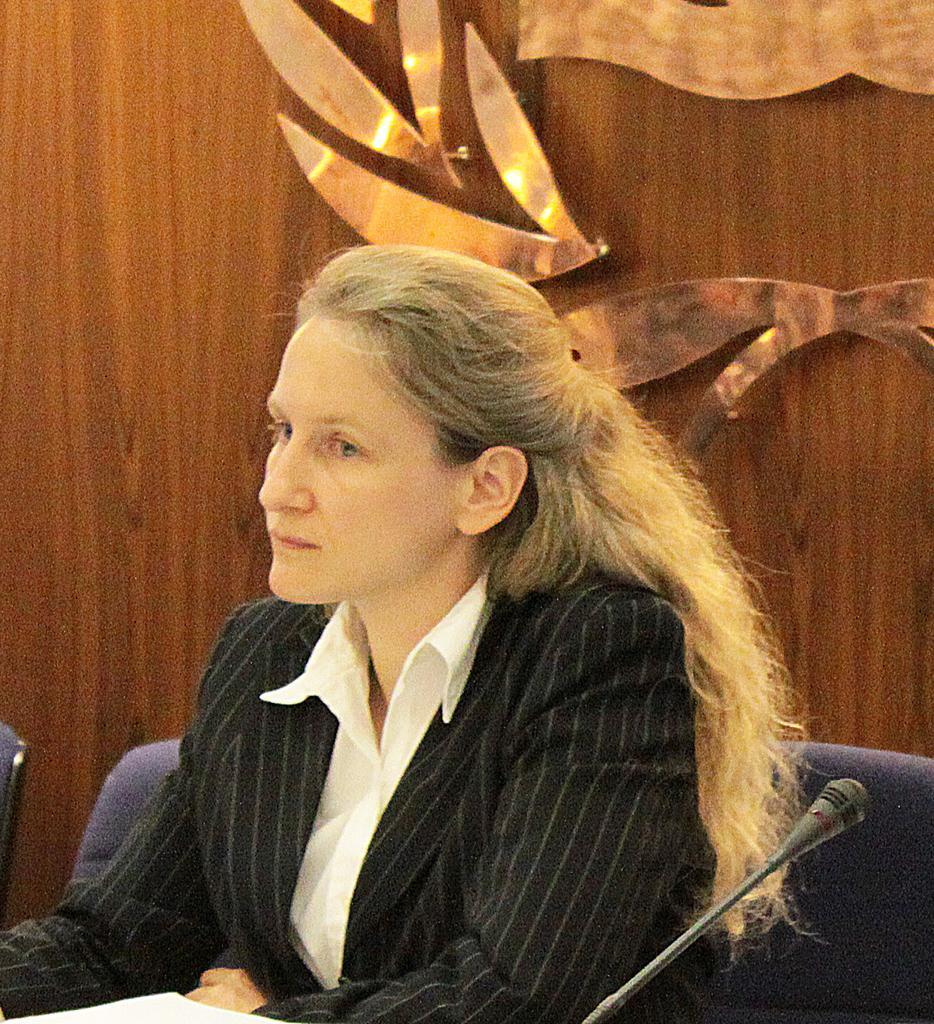In one or two sentences, can you explain what this image depicts? In this image, we can see a woman sitting on a chair. There is a microphone on the right side of the image. On the left side of the image, we can see chairs. In the background, we can see gold color objects on the wooden object. 